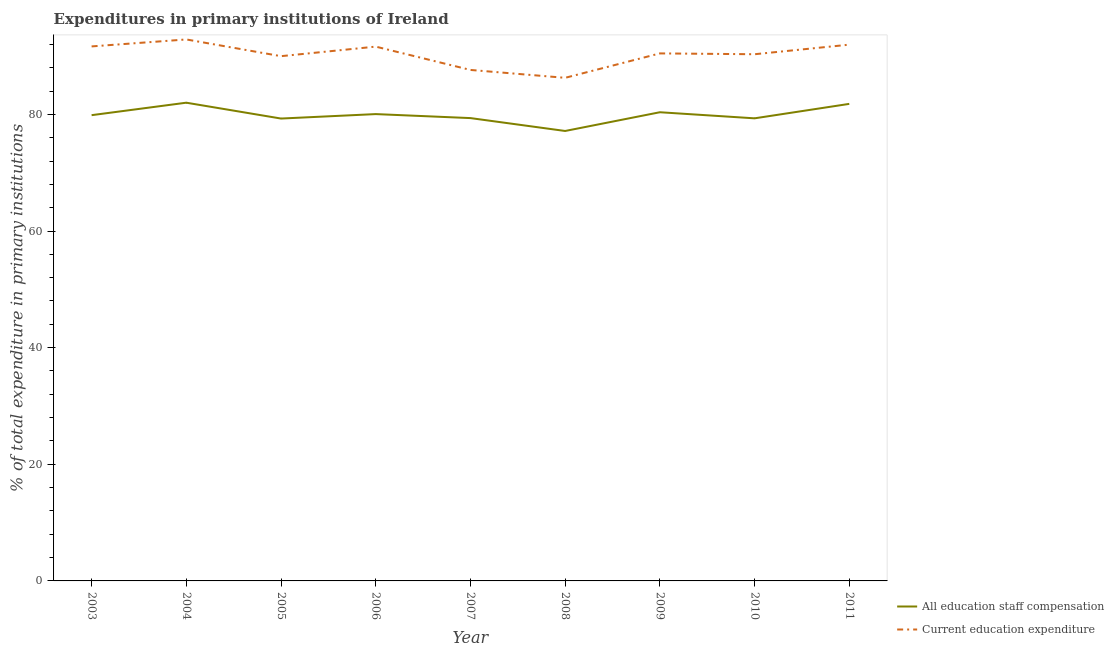How many different coloured lines are there?
Your response must be concise. 2. Does the line corresponding to expenditure in education intersect with the line corresponding to expenditure in staff compensation?
Ensure brevity in your answer.  No. Is the number of lines equal to the number of legend labels?
Provide a succinct answer. Yes. What is the expenditure in staff compensation in 2010?
Provide a short and direct response. 79.32. Across all years, what is the maximum expenditure in education?
Your answer should be compact. 92.85. Across all years, what is the minimum expenditure in education?
Make the answer very short. 86.27. What is the total expenditure in staff compensation in the graph?
Make the answer very short. 719.21. What is the difference between the expenditure in education in 2008 and that in 2010?
Offer a terse response. -4.04. What is the difference between the expenditure in education in 2007 and the expenditure in staff compensation in 2006?
Offer a terse response. 7.57. What is the average expenditure in education per year?
Your response must be concise. 90.3. In the year 2003, what is the difference between the expenditure in education and expenditure in staff compensation?
Offer a very short reply. 11.79. What is the ratio of the expenditure in staff compensation in 2004 to that in 2005?
Make the answer very short. 1.03. Is the difference between the expenditure in education in 2009 and 2010 greater than the difference between the expenditure in staff compensation in 2009 and 2010?
Give a very brief answer. No. What is the difference between the highest and the second highest expenditure in staff compensation?
Ensure brevity in your answer.  0.2. What is the difference between the highest and the lowest expenditure in education?
Keep it short and to the point. 6.58. How many lines are there?
Offer a terse response. 2. Are the values on the major ticks of Y-axis written in scientific E-notation?
Your answer should be compact. No. How many legend labels are there?
Your answer should be very brief. 2. What is the title of the graph?
Keep it short and to the point. Expenditures in primary institutions of Ireland. What is the label or title of the X-axis?
Your response must be concise. Year. What is the label or title of the Y-axis?
Your answer should be very brief. % of total expenditure in primary institutions. What is the % of total expenditure in primary institutions of All education staff compensation in 2003?
Your answer should be very brief. 79.87. What is the % of total expenditure in primary institutions in Current education expenditure in 2003?
Your response must be concise. 91.65. What is the % of total expenditure in primary institutions in All education staff compensation in 2004?
Your answer should be compact. 82. What is the % of total expenditure in primary institutions in Current education expenditure in 2004?
Provide a succinct answer. 92.85. What is the % of total expenditure in primary institutions in All education staff compensation in 2005?
Ensure brevity in your answer.  79.29. What is the % of total expenditure in primary institutions of Current education expenditure in 2005?
Ensure brevity in your answer.  89.98. What is the % of total expenditure in primary institutions in All education staff compensation in 2006?
Provide a short and direct response. 80.05. What is the % of total expenditure in primary institutions of Current education expenditure in 2006?
Make the answer very short. 91.62. What is the % of total expenditure in primary institutions in All education staff compensation in 2007?
Ensure brevity in your answer.  79.36. What is the % of total expenditure in primary institutions in Current education expenditure in 2007?
Provide a succinct answer. 87.62. What is the % of total expenditure in primary institutions in All education staff compensation in 2008?
Your answer should be compact. 77.15. What is the % of total expenditure in primary institutions of Current education expenditure in 2008?
Provide a short and direct response. 86.27. What is the % of total expenditure in primary institutions of All education staff compensation in 2009?
Offer a very short reply. 80.37. What is the % of total expenditure in primary institutions in Current education expenditure in 2009?
Offer a very short reply. 90.46. What is the % of total expenditure in primary institutions in All education staff compensation in 2010?
Your answer should be very brief. 79.32. What is the % of total expenditure in primary institutions of Current education expenditure in 2010?
Keep it short and to the point. 90.31. What is the % of total expenditure in primary institutions of All education staff compensation in 2011?
Ensure brevity in your answer.  81.8. What is the % of total expenditure in primary institutions of Current education expenditure in 2011?
Provide a succinct answer. 91.96. Across all years, what is the maximum % of total expenditure in primary institutions of All education staff compensation?
Your answer should be very brief. 82. Across all years, what is the maximum % of total expenditure in primary institutions in Current education expenditure?
Ensure brevity in your answer.  92.85. Across all years, what is the minimum % of total expenditure in primary institutions in All education staff compensation?
Keep it short and to the point. 77.15. Across all years, what is the minimum % of total expenditure in primary institutions of Current education expenditure?
Your answer should be very brief. 86.27. What is the total % of total expenditure in primary institutions in All education staff compensation in the graph?
Offer a terse response. 719.21. What is the total % of total expenditure in primary institutions of Current education expenditure in the graph?
Keep it short and to the point. 812.72. What is the difference between the % of total expenditure in primary institutions in All education staff compensation in 2003 and that in 2004?
Keep it short and to the point. -2.14. What is the difference between the % of total expenditure in primary institutions of Current education expenditure in 2003 and that in 2004?
Your response must be concise. -1.19. What is the difference between the % of total expenditure in primary institutions of All education staff compensation in 2003 and that in 2005?
Your response must be concise. 0.58. What is the difference between the % of total expenditure in primary institutions in Current education expenditure in 2003 and that in 2005?
Make the answer very short. 1.67. What is the difference between the % of total expenditure in primary institutions of All education staff compensation in 2003 and that in 2006?
Provide a succinct answer. -0.18. What is the difference between the % of total expenditure in primary institutions of Current education expenditure in 2003 and that in 2006?
Make the answer very short. 0.04. What is the difference between the % of total expenditure in primary institutions of All education staff compensation in 2003 and that in 2007?
Offer a very short reply. 0.5. What is the difference between the % of total expenditure in primary institutions of Current education expenditure in 2003 and that in 2007?
Offer a terse response. 4.03. What is the difference between the % of total expenditure in primary institutions in All education staff compensation in 2003 and that in 2008?
Ensure brevity in your answer.  2.71. What is the difference between the % of total expenditure in primary institutions of Current education expenditure in 2003 and that in 2008?
Offer a very short reply. 5.39. What is the difference between the % of total expenditure in primary institutions in All education staff compensation in 2003 and that in 2009?
Offer a terse response. -0.5. What is the difference between the % of total expenditure in primary institutions of Current education expenditure in 2003 and that in 2009?
Provide a succinct answer. 1.2. What is the difference between the % of total expenditure in primary institutions of All education staff compensation in 2003 and that in 2010?
Your response must be concise. 0.54. What is the difference between the % of total expenditure in primary institutions of Current education expenditure in 2003 and that in 2010?
Your answer should be very brief. 1.34. What is the difference between the % of total expenditure in primary institutions in All education staff compensation in 2003 and that in 2011?
Ensure brevity in your answer.  -1.94. What is the difference between the % of total expenditure in primary institutions in Current education expenditure in 2003 and that in 2011?
Make the answer very short. -0.3. What is the difference between the % of total expenditure in primary institutions in All education staff compensation in 2004 and that in 2005?
Keep it short and to the point. 2.72. What is the difference between the % of total expenditure in primary institutions in Current education expenditure in 2004 and that in 2005?
Offer a terse response. 2.87. What is the difference between the % of total expenditure in primary institutions of All education staff compensation in 2004 and that in 2006?
Keep it short and to the point. 1.95. What is the difference between the % of total expenditure in primary institutions in Current education expenditure in 2004 and that in 2006?
Your answer should be very brief. 1.23. What is the difference between the % of total expenditure in primary institutions of All education staff compensation in 2004 and that in 2007?
Provide a succinct answer. 2.64. What is the difference between the % of total expenditure in primary institutions in Current education expenditure in 2004 and that in 2007?
Provide a short and direct response. 5.23. What is the difference between the % of total expenditure in primary institutions of All education staff compensation in 2004 and that in 2008?
Keep it short and to the point. 4.85. What is the difference between the % of total expenditure in primary institutions in Current education expenditure in 2004 and that in 2008?
Keep it short and to the point. 6.58. What is the difference between the % of total expenditure in primary institutions in All education staff compensation in 2004 and that in 2009?
Provide a short and direct response. 1.64. What is the difference between the % of total expenditure in primary institutions in Current education expenditure in 2004 and that in 2009?
Provide a short and direct response. 2.39. What is the difference between the % of total expenditure in primary institutions of All education staff compensation in 2004 and that in 2010?
Provide a short and direct response. 2.68. What is the difference between the % of total expenditure in primary institutions in Current education expenditure in 2004 and that in 2010?
Make the answer very short. 2.54. What is the difference between the % of total expenditure in primary institutions of All education staff compensation in 2004 and that in 2011?
Give a very brief answer. 0.2. What is the difference between the % of total expenditure in primary institutions in Current education expenditure in 2004 and that in 2011?
Offer a terse response. 0.89. What is the difference between the % of total expenditure in primary institutions in All education staff compensation in 2005 and that in 2006?
Ensure brevity in your answer.  -0.76. What is the difference between the % of total expenditure in primary institutions in Current education expenditure in 2005 and that in 2006?
Make the answer very short. -1.64. What is the difference between the % of total expenditure in primary institutions in All education staff compensation in 2005 and that in 2007?
Give a very brief answer. -0.08. What is the difference between the % of total expenditure in primary institutions of Current education expenditure in 2005 and that in 2007?
Provide a short and direct response. 2.36. What is the difference between the % of total expenditure in primary institutions in All education staff compensation in 2005 and that in 2008?
Provide a succinct answer. 2.13. What is the difference between the % of total expenditure in primary institutions in Current education expenditure in 2005 and that in 2008?
Ensure brevity in your answer.  3.71. What is the difference between the % of total expenditure in primary institutions of All education staff compensation in 2005 and that in 2009?
Your answer should be very brief. -1.08. What is the difference between the % of total expenditure in primary institutions in Current education expenditure in 2005 and that in 2009?
Your response must be concise. -0.47. What is the difference between the % of total expenditure in primary institutions in All education staff compensation in 2005 and that in 2010?
Ensure brevity in your answer.  -0.04. What is the difference between the % of total expenditure in primary institutions in Current education expenditure in 2005 and that in 2010?
Provide a succinct answer. -0.33. What is the difference between the % of total expenditure in primary institutions of All education staff compensation in 2005 and that in 2011?
Keep it short and to the point. -2.51. What is the difference between the % of total expenditure in primary institutions in Current education expenditure in 2005 and that in 2011?
Your response must be concise. -1.97. What is the difference between the % of total expenditure in primary institutions in All education staff compensation in 2006 and that in 2007?
Make the answer very short. 0.68. What is the difference between the % of total expenditure in primary institutions in Current education expenditure in 2006 and that in 2007?
Provide a short and direct response. 4. What is the difference between the % of total expenditure in primary institutions in All education staff compensation in 2006 and that in 2008?
Make the answer very short. 2.89. What is the difference between the % of total expenditure in primary institutions in Current education expenditure in 2006 and that in 2008?
Your answer should be very brief. 5.35. What is the difference between the % of total expenditure in primary institutions of All education staff compensation in 2006 and that in 2009?
Ensure brevity in your answer.  -0.32. What is the difference between the % of total expenditure in primary institutions of Current education expenditure in 2006 and that in 2009?
Offer a terse response. 1.16. What is the difference between the % of total expenditure in primary institutions in All education staff compensation in 2006 and that in 2010?
Your response must be concise. 0.73. What is the difference between the % of total expenditure in primary institutions in Current education expenditure in 2006 and that in 2010?
Offer a terse response. 1.31. What is the difference between the % of total expenditure in primary institutions in All education staff compensation in 2006 and that in 2011?
Keep it short and to the point. -1.75. What is the difference between the % of total expenditure in primary institutions of Current education expenditure in 2006 and that in 2011?
Provide a short and direct response. -0.34. What is the difference between the % of total expenditure in primary institutions of All education staff compensation in 2007 and that in 2008?
Your answer should be very brief. 2.21. What is the difference between the % of total expenditure in primary institutions of Current education expenditure in 2007 and that in 2008?
Your answer should be very brief. 1.35. What is the difference between the % of total expenditure in primary institutions in All education staff compensation in 2007 and that in 2009?
Your answer should be compact. -1. What is the difference between the % of total expenditure in primary institutions of Current education expenditure in 2007 and that in 2009?
Offer a terse response. -2.84. What is the difference between the % of total expenditure in primary institutions of All education staff compensation in 2007 and that in 2010?
Keep it short and to the point. 0.04. What is the difference between the % of total expenditure in primary institutions in Current education expenditure in 2007 and that in 2010?
Offer a very short reply. -2.69. What is the difference between the % of total expenditure in primary institutions of All education staff compensation in 2007 and that in 2011?
Provide a succinct answer. -2.44. What is the difference between the % of total expenditure in primary institutions of Current education expenditure in 2007 and that in 2011?
Keep it short and to the point. -4.33. What is the difference between the % of total expenditure in primary institutions in All education staff compensation in 2008 and that in 2009?
Your response must be concise. -3.21. What is the difference between the % of total expenditure in primary institutions of Current education expenditure in 2008 and that in 2009?
Offer a terse response. -4.19. What is the difference between the % of total expenditure in primary institutions in All education staff compensation in 2008 and that in 2010?
Offer a very short reply. -2.17. What is the difference between the % of total expenditure in primary institutions of Current education expenditure in 2008 and that in 2010?
Provide a succinct answer. -4.04. What is the difference between the % of total expenditure in primary institutions of All education staff compensation in 2008 and that in 2011?
Provide a short and direct response. -4.65. What is the difference between the % of total expenditure in primary institutions of Current education expenditure in 2008 and that in 2011?
Give a very brief answer. -5.69. What is the difference between the % of total expenditure in primary institutions of All education staff compensation in 2009 and that in 2010?
Give a very brief answer. 1.04. What is the difference between the % of total expenditure in primary institutions of Current education expenditure in 2009 and that in 2010?
Make the answer very short. 0.14. What is the difference between the % of total expenditure in primary institutions of All education staff compensation in 2009 and that in 2011?
Your response must be concise. -1.43. What is the difference between the % of total expenditure in primary institutions in Current education expenditure in 2009 and that in 2011?
Offer a terse response. -1.5. What is the difference between the % of total expenditure in primary institutions in All education staff compensation in 2010 and that in 2011?
Offer a terse response. -2.48. What is the difference between the % of total expenditure in primary institutions in Current education expenditure in 2010 and that in 2011?
Keep it short and to the point. -1.64. What is the difference between the % of total expenditure in primary institutions of All education staff compensation in 2003 and the % of total expenditure in primary institutions of Current education expenditure in 2004?
Provide a short and direct response. -12.98. What is the difference between the % of total expenditure in primary institutions in All education staff compensation in 2003 and the % of total expenditure in primary institutions in Current education expenditure in 2005?
Your response must be concise. -10.12. What is the difference between the % of total expenditure in primary institutions of All education staff compensation in 2003 and the % of total expenditure in primary institutions of Current education expenditure in 2006?
Ensure brevity in your answer.  -11.75. What is the difference between the % of total expenditure in primary institutions of All education staff compensation in 2003 and the % of total expenditure in primary institutions of Current education expenditure in 2007?
Ensure brevity in your answer.  -7.76. What is the difference between the % of total expenditure in primary institutions in All education staff compensation in 2003 and the % of total expenditure in primary institutions in Current education expenditure in 2008?
Offer a terse response. -6.4. What is the difference between the % of total expenditure in primary institutions of All education staff compensation in 2003 and the % of total expenditure in primary institutions of Current education expenditure in 2009?
Offer a very short reply. -10.59. What is the difference between the % of total expenditure in primary institutions of All education staff compensation in 2003 and the % of total expenditure in primary institutions of Current education expenditure in 2010?
Give a very brief answer. -10.45. What is the difference between the % of total expenditure in primary institutions in All education staff compensation in 2003 and the % of total expenditure in primary institutions in Current education expenditure in 2011?
Your answer should be very brief. -12.09. What is the difference between the % of total expenditure in primary institutions in All education staff compensation in 2004 and the % of total expenditure in primary institutions in Current education expenditure in 2005?
Your answer should be very brief. -7.98. What is the difference between the % of total expenditure in primary institutions of All education staff compensation in 2004 and the % of total expenditure in primary institutions of Current education expenditure in 2006?
Provide a short and direct response. -9.62. What is the difference between the % of total expenditure in primary institutions of All education staff compensation in 2004 and the % of total expenditure in primary institutions of Current education expenditure in 2007?
Offer a very short reply. -5.62. What is the difference between the % of total expenditure in primary institutions in All education staff compensation in 2004 and the % of total expenditure in primary institutions in Current education expenditure in 2008?
Provide a succinct answer. -4.27. What is the difference between the % of total expenditure in primary institutions of All education staff compensation in 2004 and the % of total expenditure in primary institutions of Current education expenditure in 2009?
Your response must be concise. -8.45. What is the difference between the % of total expenditure in primary institutions of All education staff compensation in 2004 and the % of total expenditure in primary institutions of Current education expenditure in 2010?
Keep it short and to the point. -8.31. What is the difference between the % of total expenditure in primary institutions in All education staff compensation in 2004 and the % of total expenditure in primary institutions in Current education expenditure in 2011?
Provide a short and direct response. -9.95. What is the difference between the % of total expenditure in primary institutions in All education staff compensation in 2005 and the % of total expenditure in primary institutions in Current education expenditure in 2006?
Make the answer very short. -12.33. What is the difference between the % of total expenditure in primary institutions of All education staff compensation in 2005 and the % of total expenditure in primary institutions of Current education expenditure in 2007?
Provide a short and direct response. -8.33. What is the difference between the % of total expenditure in primary institutions of All education staff compensation in 2005 and the % of total expenditure in primary institutions of Current education expenditure in 2008?
Provide a succinct answer. -6.98. What is the difference between the % of total expenditure in primary institutions of All education staff compensation in 2005 and the % of total expenditure in primary institutions of Current education expenditure in 2009?
Offer a terse response. -11.17. What is the difference between the % of total expenditure in primary institutions in All education staff compensation in 2005 and the % of total expenditure in primary institutions in Current education expenditure in 2010?
Your answer should be very brief. -11.03. What is the difference between the % of total expenditure in primary institutions in All education staff compensation in 2005 and the % of total expenditure in primary institutions in Current education expenditure in 2011?
Provide a short and direct response. -12.67. What is the difference between the % of total expenditure in primary institutions of All education staff compensation in 2006 and the % of total expenditure in primary institutions of Current education expenditure in 2007?
Keep it short and to the point. -7.57. What is the difference between the % of total expenditure in primary institutions of All education staff compensation in 2006 and the % of total expenditure in primary institutions of Current education expenditure in 2008?
Provide a succinct answer. -6.22. What is the difference between the % of total expenditure in primary institutions of All education staff compensation in 2006 and the % of total expenditure in primary institutions of Current education expenditure in 2009?
Provide a short and direct response. -10.41. What is the difference between the % of total expenditure in primary institutions of All education staff compensation in 2006 and the % of total expenditure in primary institutions of Current education expenditure in 2010?
Provide a short and direct response. -10.27. What is the difference between the % of total expenditure in primary institutions in All education staff compensation in 2006 and the % of total expenditure in primary institutions in Current education expenditure in 2011?
Keep it short and to the point. -11.91. What is the difference between the % of total expenditure in primary institutions in All education staff compensation in 2007 and the % of total expenditure in primary institutions in Current education expenditure in 2008?
Provide a succinct answer. -6.91. What is the difference between the % of total expenditure in primary institutions in All education staff compensation in 2007 and the % of total expenditure in primary institutions in Current education expenditure in 2009?
Your answer should be very brief. -11.09. What is the difference between the % of total expenditure in primary institutions of All education staff compensation in 2007 and the % of total expenditure in primary institutions of Current education expenditure in 2010?
Offer a very short reply. -10.95. What is the difference between the % of total expenditure in primary institutions of All education staff compensation in 2007 and the % of total expenditure in primary institutions of Current education expenditure in 2011?
Keep it short and to the point. -12.59. What is the difference between the % of total expenditure in primary institutions of All education staff compensation in 2008 and the % of total expenditure in primary institutions of Current education expenditure in 2009?
Ensure brevity in your answer.  -13.3. What is the difference between the % of total expenditure in primary institutions in All education staff compensation in 2008 and the % of total expenditure in primary institutions in Current education expenditure in 2010?
Provide a short and direct response. -13.16. What is the difference between the % of total expenditure in primary institutions of All education staff compensation in 2008 and the % of total expenditure in primary institutions of Current education expenditure in 2011?
Keep it short and to the point. -14.8. What is the difference between the % of total expenditure in primary institutions in All education staff compensation in 2009 and the % of total expenditure in primary institutions in Current education expenditure in 2010?
Give a very brief answer. -9.95. What is the difference between the % of total expenditure in primary institutions in All education staff compensation in 2009 and the % of total expenditure in primary institutions in Current education expenditure in 2011?
Provide a succinct answer. -11.59. What is the difference between the % of total expenditure in primary institutions of All education staff compensation in 2010 and the % of total expenditure in primary institutions of Current education expenditure in 2011?
Your answer should be compact. -12.63. What is the average % of total expenditure in primary institutions in All education staff compensation per year?
Make the answer very short. 79.91. What is the average % of total expenditure in primary institutions of Current education expenditure per year?
Make the answer very short. 90.3. In the year 2003, what is the difference between the % of total expenditure in primary institutions in All education staff compensation and % of total expenditure in primary institutions in Current education expenditure?
Make the answer very short. -11.79. In the year 2004, what is the difference between the % of total expenditure in primary institutions of All education staff compensation and % of total expenditure in primary institutions of Current education expenditure?
Offer a terse response. -10.85. In the year 2005, what is the difference between the % of total expenditure in primary institutions of All education staff compensation and % of total expenditure in primary institutions of Current education expenditure?
Your response must be concise. -10.7. In the year 2006, what is the difference between the % of total expenditure in primary institutions of All education staff compensation and % of total expenditure in primary institutions of Current education expenditure?
Your response must be concise. -11.57. In the year 2007, what is the difference between the % of total expenditure in primary institutions in All education staff compensation and % of total expenditure in primary institutions in Current education expenditure?
Your answer should be compact. -8.26. In the year 2008, what is the difference between the % of total expenditure in primary institutions in All education staff compensation and % of total expenditure in primary institutions in Current education expenditure?
Give a very brief answer. -9.12. In the year 2009, what is the difference between the % of total expenditure in primary institutions in All education staff compensation and % of total expenditure in primary institutions in Current education expenditure?
Your answer should be compact. -10.09. In the year 2010, what is the difference between the % of total expenditure in primary institutions of All education staff compensation and % of total expenditure in primary institutions of Current education expenditure?
Ensure brevity in your answer.  -10.99. In the year 2011, what is the difference between the % of total expenditure in primary institutions of All education staff compensation and % of total expenditure in primary institutions of Current education expenditure?
Offer a very short reply. -10.15. What is the ratio of the % of total expenditure in primary institutions of All education staff compensation in 2003 to that in 2004?
Your response must be concise. 0.97. What is the ratio of the % of total expenditure in primary institutions of Current education expenditure in 2003 to that in 2004?
Ensure brevity in your answer.  0.99. What is the ratio of the % of total expenditure in primary institutions in All education staff compensation in 2003 to that in 2005?
Provide a short and direct response. 1.01. What is the ratio of the % of total expenditure in primary institutions in Current education expenditure in 2003 to that in 2005?
Your answer should be compact. 1.02. What is the ratio of the % of total expenditure in primary institutions of All education staff compensation in 2003 to that in 2007?
Keep it short and to the point. 1.01. What is the ratio of the % of total expenditure in primary institutions of Current education expenditure in 2003 to that in 2007?
Give a very brief answer. 1.05. What is the ratio of the % of total expenditure in primary institutions in All education staff compensation in 2003 to that in 2008?
Your answer should be very brief. 1.04. What is the ratio of the % of total expenditure in primary institutions in Current education expenditure in 2003 to that in 2008?
Ensure brevity in your answer.  1.06. What is the ratio of the % of total expenditure in primary institutions in All education staff compensation in 2003 to that in 2009?
Your answer should be compact. 0.99. What is the ratio of the % of total expenditure in primary institutions in Current education expenditure in 2003 to that in 2009?
Provide a succinct answer. 1.01. What is the ratio of the % of total expenditure in primary institutions of All education staff compensation in 2003 to that in 2010?
Your answer should be compact. 1.01. What is the ratio of the % of total expenditure in primary institutions in Current education expenditure in 2003 to that in 2010?
Your answer should be very brief. 1.01. What is the ratio of the % of total expenditure in primary institutions of All education staff compensation in 2003 to that in 2011?
Your response must be concise. 0.98. What is the ratio of the % of total expenditure in primary institutions of All education staff compensation in 2004 to that in 2005?
Your answer should be compact. 1.03. What is the ratio of the % of total expenditure in primary institutions of Current education expenditure in 2004 to that in 2005?
Give a very brief answer. 1.03. What is the ratio of the % of total expenditure in primary institutions in All education staff compensation in 2004 to that in 2006?
Provide a short and direct response. 1.02. What is the ratio of the % of total expenditure in primary institutions in Current education expenditure in 2004 to that in 2006?
Your answer should be very brief. 1.01. What is the ratio of the % of total expenditure in primary institutions of All education staff compensation in 2004 to that in 2007?
Ensure brevity in your answer.  1.03. What is the ratio of the % of total expenditure in primary institutions in Current education expenditure in 2004 to that in 2007?
Offer a terse response. 1.06. What is the ratio of the % of total expenditure in primary institutions in All education staff compensation in 2004 to that in 2008?
Your response must be concise. 1.06. What is the ratio of the % of total expenditure in primary institutions in Current education expenditure in 2004 to that in 2008?
Provide a succinct answer. 1.08. What is the ratio of the % of total expenditure in primary institutions of All education staff compensation in 2004 to that in 2009?
Your answer should be compact. 1.02. What is the ratio of the % of total expenditure in primary institutions in Current education expenditure in 2004 to that in 2009?
Make the answer very short. 1.03. What is the ratio of the % of total expenditure in primary institutions in All education staff compensation in 2004 to that in 2010?
Keep it short and to the point. 1.03. What is the ratio of the % of total expenditure in primary institutions in Current education expenditure in 2004 to that in 2010?
Offer a very short reply. 1.03. What is the ratio of the % of total expenditure in primary institutions of All education staff compensation in 2004 to that in 2011?
Offer a terse response. 1. What is the ratio of the % of total expenditure in primary institutions in Current education expenditure in 2004 to that in 2011?
Your answer should be compact. 1.01. What is the ratio of the % of total expenditure in primary institutions in All education staff compensation in 2005 to that in 2006?
Your response must be concise. 0.99. What is the ratio of the % of total expenditure in primary institutions of Current education expenditure in 2005 to that in 2006?
Provide a short and direct response. 0.98. What is the ratio of the % of total expenditure in primary institutions of All education staff compensation in 2005 to that in 2007?
Offer a very short reply. 1. What is the ratio of the % of total expenditure in primary institutions of Current education expenditure in 2005 to that in 2007?
Offer a terse response. 1.03. What is the ratio of the % of total expenditure in primary institutions in All education staff compensation in 2005 to that in 2008?
Your answer should be very brief. 1.03. What is the ratio of the % of total expenditure in primary institutions in Current education expenditure in 2005 to that in 2008?
Make the answer very short. 1.04. What is the ratio of the % of total expenditure in primary institutions of All education staff compensation in 2005 to that in 2009?
Keep it short and to the point. 0.99. What is the ratio of the % of total expenditure in primary institutions in Current education expenditure in 2005 to that in 2009?
Provide a succinct answer. 0.99. What is the ratio of the % of total expenditure in primary institutions in All education staff compensation in 2005 to that in 2010?
Your answer should be compact. 1. What is the ratio of the % of total expenditure in primary institutions in All education staff compensation in 2005 to that in 2011?
Make the answer very short. 0.97. What is the ratio of the % of total expenditure in primary institutions of Current education expenditure in 2005 to that in 2011?
Keep it short and to the point. 0.98. What is the ratio of the % of total expenditure in primary institutions in All education staff compensation in 2006 to that in 2007?
Give a very brief answer. 1.01. What is the ratio of the % of total expenditure in primary institutions of Current education expenditure in 2006 to that in 2007?
Provide a short and direct response. 1.05. What is the ratio of the % of total expenditure in primary institutions of All education staff compensation in 2006 to that in 2008?
Make the answer very short. 1.04. What is the ratio of the % of total expenditure in primary institutions of Current education expenditure in 2006 to that in 2008?
Your response must be concise. 1.06. What is the ratio of the % of total expenditure in primary institutions of All education staff compensation in 2006 to that in 2009?
Make the answer very short. 1. What is the ratio of the % of total expenditure in primary institutions in Current education expenditure in 2006 to that in 2009?
Give a very brief answer. 1.01. What is the ratio of the % of total expenditure in primary institutions of All education staff compensation in 2006 to that in 2010?
Your response must be concise. 1.01. What is the ratio of the % of total expenditure in primary institutions in Current education expenditure in 2006 to that in 2010?
Keep it short and to the point. 1.01. What is the ratio of the % of total expenditure in primary institutions in All education staff compensation in 2006 to that in 2011?
Your answer should be compact. 0.98. What is the ratio of the % of total expenditure in primary institutions in All education staff compensation in 2007 to that in 2008?
Offer a terse response. 1.03. What is the ratio of the % of total expenditure in primary institutions in Current education expenditure in 2007 to that in 2008?
Keep it short and to the point. 1.02. What is the ratio of the % of total expenditure in primary institutions in All education staff compensation in 2007 to that in 2009?
Keep it short and to the point. 0.99. What is the ratio of the % of total expenditure in primary institutions in Current education expenditure in 2007 to that in 2009?
Your response must be concise. 0.97. What is the ratio of the % of total expenditure in primary institutions of Current education expenditure in 2007 to that in 2010?
Offer a very short reply. 0.97. What is the ratio of the % of total expenditure in primary institutions in All education staff compensation in 2007 to that in 2011?
Offer a very short reply. 0.97. What is the ratio of the % of total expenditure in primary institutions of Current education expenditure in 2007 to that in 2011?
Offer a very short reply. 0.95. What is the ratio of the % of total expenditure in primary institutions in All education staff compensation in 2008 to that in 2009?
Offer a very short reply. 0.96. What is the ratio of the % of total expenditure in primary institutions of Current education expenditure in 2008 to that in 2009?
Give a very brief answer. 0.95. What is the ratio of the % of total expenditure in primary institutions of All education staff compensation in 2008 to that in 2010?
Offer a terse response. 0.97. What is the ratio of the % of total expenditure in primary institutions in Current education expenditure in 2008 to that in 2010?
Make the answer very short. 0.96. What is the ratio of the % of total expenditure in primary institutions of All education staff compensation in 2008 to that in 2011?
Your answer should be very brief. 0.94. What is the ratio of the % of total expenditure in primary institutions of Current education expenditure in 2008 to that in 2011?
Your answer should be compact. 0.94. What is the ratio of the % of total expenditure in primary institutions of All education staff compensation in 2009 to that in 2010?
Your answer should be compact. 1.01. What is the ratio of the % of total expenditure in primary institutions in Current education expenditure in 2009 to that in 2010?
Your answer should be compact. 1. What is the ratio of the % of total expenditure in primary institutions of All education staff compensation in 2009 to that in 2011?
Make the answer very short. 0.98. What is the ratio of the % of total expenditure in primary institutions in Current education expenditure in 2009 to that in 2011?
Ensure brevity in your answer.  0.98. What is the ratio of the % of total expenditure in primary institutions of All education staff compensation in 2010 to that in 2011?
Your response must be concise. 0.97. What is the ratio of the % of total expenditure in primary institutions in Current education expenditure in 2010 to that in 2011?
Provide a short and direct response. 0.98. What is the difference between the highest and the second highest % of total expenditure in primary institutions in All education staff compensation?
Give a very brief answer. 0.2. What is the difference between the highest and the second highest % of total expenditure in primary institutions in Current education expenditure?
Offer a very short reply. 0.89. What is the difference between the highest and the lowest % of total expenditure in primary institutions in All education staff compensation?
Give a very brief answer. 4.85. What is the difference between the highest and the lowest % of total expenditure in primary institutions of Current education expenditure?
Make the answer very short. 6.58. 